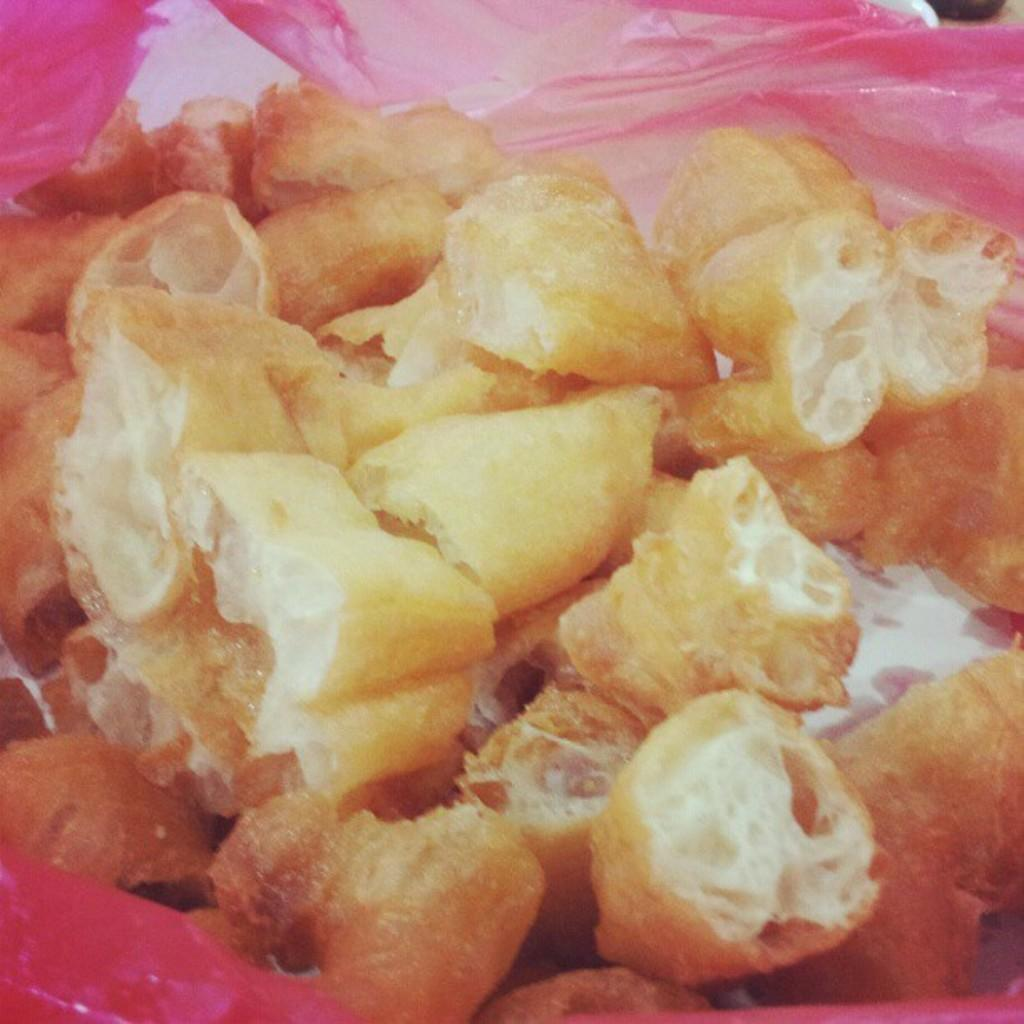What type of items can be seen in the image? There are eatables in the image. Can you describe the color and material of the cover in the background? The cover in the background is pink and made of plastic. Can you see a dog looking out of the window in the image? There is no dog or window present in the image. What type of amusement can be seen in the image? There is no amusement depicted in the image; it only features eatables and a pink color plastic cover. 